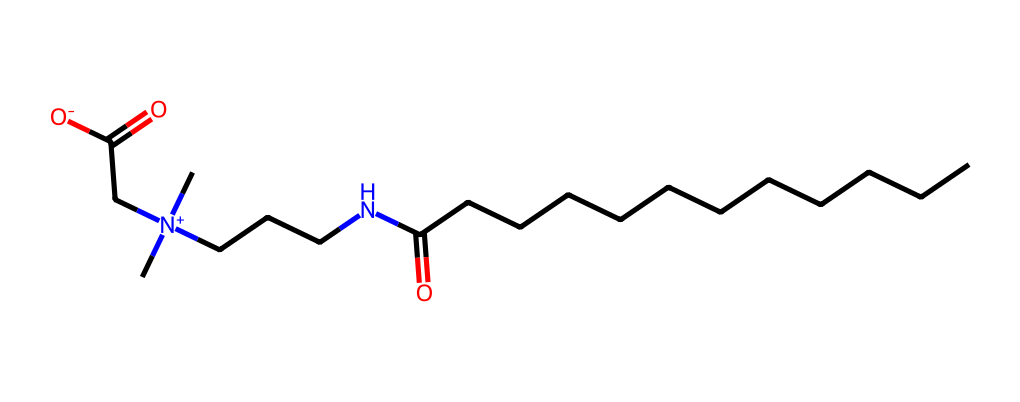What is the name of this surfactant? The chemical structure provided corresponds to cocamidopropyl betaine, which is a zwitterionic surfactant commonly used in personal care products.
Answer: cocamidopropyl betaine How many carbon atoms are in the structure? By counting the carbon atoms in the SMILES representation, we find a total of 15 carbon atoms associated with the long hydrocarbon chain and the nitrogen-containing group.
Answer: 15 What type of functional group is present in this chemical? The structural representation shows a carboxylic acid functional group (-COOH) due to the presence of the group at the end of the molecular structure next to the nitrogen.
Answer: carboxylic acid What is the charge of the quaternary ammonium group in this structure? The quaternary ammonium group represented by the nitrogen atom has a positive charge due to the four substituents attached to it, resulting in a formal positive charge.
Answer: positive How does the structure contribute to its surfactant properties? The hydrophobic hydrocarbon tail and the hydrophilic head (quaternary ammonium group and carboxylic acid) give the molecule amphiphilic characteristics, which allow it to reduce surface tension and act as a surfactant.
Answer: amphiphilic How many oxygen atoms are in the structure? Counting the oxygen atoms in the SMILES string reveals that there are 3 oxygen atoms in total present in the carboxylic acid and other functional groups.
Answer: 3 What is the significance of the N-nitrogen atom in this surfactant? The nitrogen atom in this molecule is part of the quaternary ammonium group, which is significant for its ability to interact with both both polar and non-polar substances, thereby enhancing its surfactant properties.
Answer: quaternary ammonium 